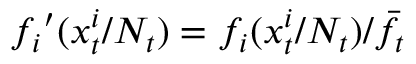Convert formula to latex. <formula><loc_0><loc_0><loc_500><loc_500>{ f _ { i } } ^ { \prime } ( x _ { t } ^ { i } / N _ { t } ) = f _ { i } ( x _ { t } ^ { i } / N _ { t } ) / \bar { f } _ { t }</formula> 